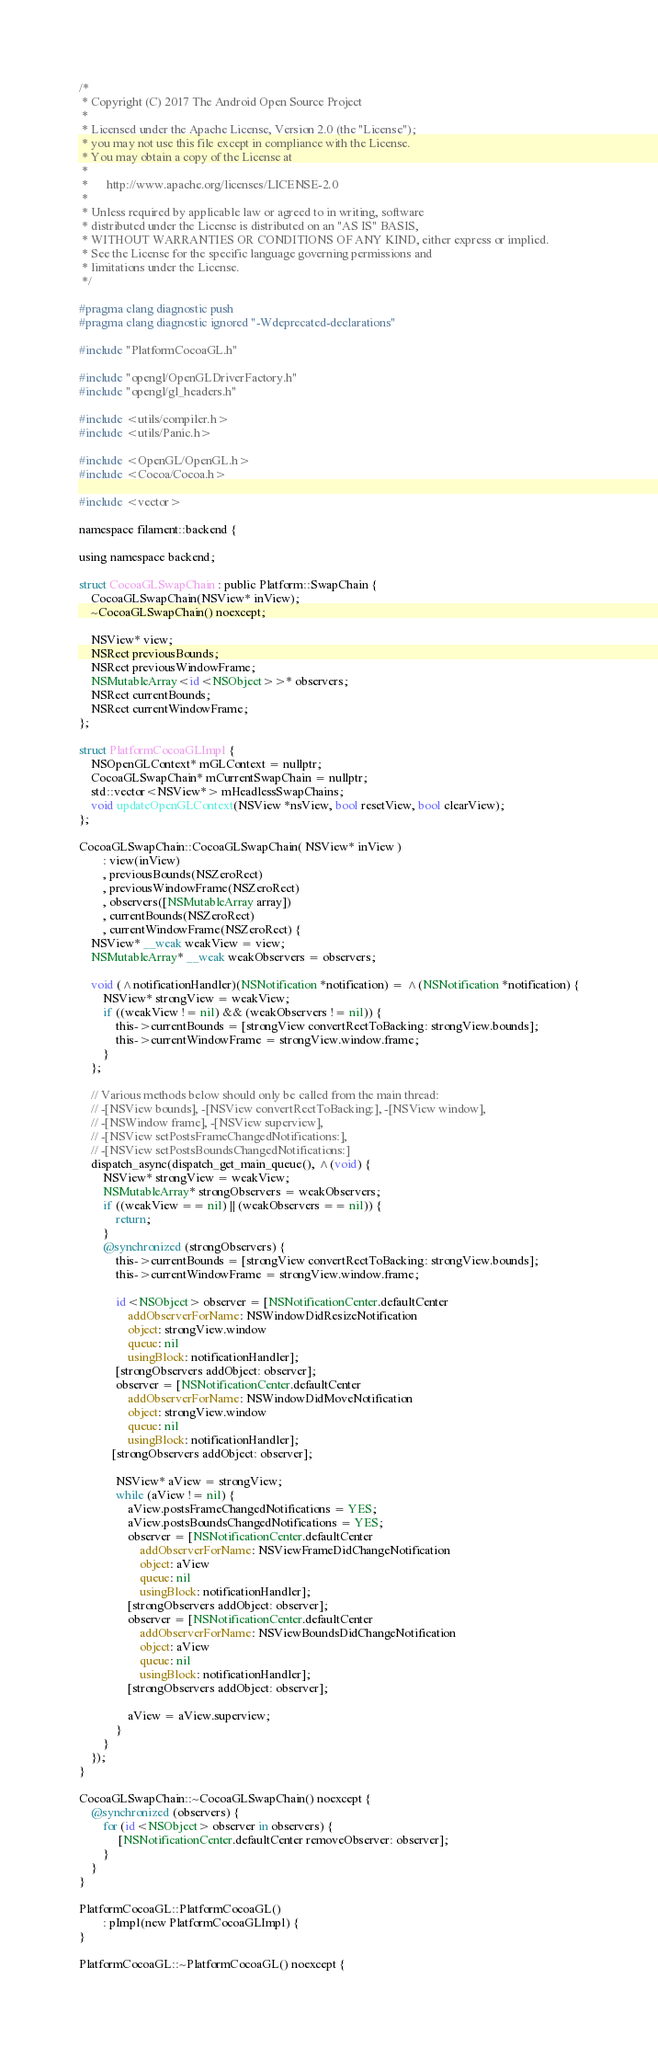<code> <loc_0><loc_0><loc_500><loc_500><_ObjectiveC_>/*
 * Copyright (C) 2017 The Android Open Source Project
 *
 * Licensed under the Apache License, Version 2.0 (the "License");
 * you may not use this file except in compliance with the License.
 * You may obtain a copy of the License at
 *
 *      http://www.apache.org/licenses/LICENSE-2.0
 *
 * Unless required by applicable law or agreed to in writing, software
 * distributed under the License is distributed on an "AS IS" BASIS,
 * WITHOUT WARRANTIES OR CONDITIONS OF ANY KIND, either express or implied.
 * See the License for the specific language governing permissions and
 * limitations under the License.
 */

#pragma clang diagnostic push
#pragma clang diagnostic ignored "-Wdeprecated-declarations"

#include "PlatformCocoaGL.h"

#include "opengl/OpenGLDriverFactory.h"
#include "opengl/gl_headers.h"

#include <utils/compiler.h>
#include <utils/Panic.h>

#include <OpenGL/OpenGL.h>
#include <Cocoa/Cocoa.h>

#include <vector>

namespace filament::backend {

using namespace backend;

struct CocoaGLSwapChain : public Platform::SwapChain {
    CocoaGLSwapChain(NSView* inView);
    ~CocoaGLSwapChain() noexcept;

    NSView* view;
    NSRect previousBounds;
    NSRect previousWindowFrame;
    NSMutableArray<id<NSObject>>* observers;
    NSRect currentBounds;
    NSRect currentWindowFrame;
};

struct PlatformCocoaGLImpl {
    NSOpenGLContext* mGLContext = nullptr;
    CocoaGLSwapChain* mCurrentSwapChain = nullptr;
    std::vector<NSView*> mHeadlessSwapChains;
    void updateOpenGLContext(NSView *nsView, bool resetView, bool clearView);
};

CocoaGLSwapChain::CocoaGLSwapChain( NSView* inView )
        : view(inView)
        , previousBounds(NSZeroRect)
        , previousWindowFrame(NSZeroRect)
        , observers([NSMutableArray array])
        , currentBounds(NSZeroRect)
        , currentWindowFrame(NSZeroRect) {
    NSView* __weak weakView = view;
    NSMutableArray* __weak weakObservers = observers;
    
    void (^notificationHandler)(NSNotification *notification) = ^(NSNotification *notification) {
        NSView* strongView = weakView;
        if ((weakView != nil) && (weakObservers != nil)) {
            this->currentBounds = [strongView convertRectToBacking: strongView.bounds];
            this->currentWindowFrame = strongView.window.frame;
        }
    };
    
    // Various methods below should only be called from the main thread:
    // -[NSView bounds], -[NSView convertRectToBacking:], -[NSView window],
    // -[NSWindow frame], -[NSView superview],
    // -[NSView setPostsFrameChangedNotifications:],
    // -[NSView setPostsBoundsChangedNotifications:]
    dispatch_async(dispatch_get_main_queue(), ^(void) {
        NSView* strongView = weakView;
        NSMutableArray* strongObservers = weakObservers;
        if ((weakView == nil) || (weakObservers == nil)) {
            return;
        }
        @synchronized (strongObservers) {
            this->currentBounds = [strongView convertRectToBacking: strongView.bounds];
            this->currentWindowFrame = strongView.window.frame;

            id<NSObject> observer = [NSNotificationCenter.defaultCenter
                addObserverForName: NSWindowDidResizeNotification
                object: strongView.window
                queue: nil
                usingBlock: notificationHandler];
            [strongObservers addObject: observer];
            observer = [NSNotificationCenter.defaultCenter
                addObserverForName: NSWindowDidMoveNotification
                object: strongView.window
                queue: nil
                usingBlock: notificationHandler];
           [strongObservers addObject: observer];

            NSView* aView = strongView;
            while (aView != nil) {
                aView.postsFrameChangedNotifications = YES;
                aView.postsBoundsChangedNotifications = YES;
                observer = [NSNotificationCenter.defaultCenter
                    addObserverForName: NSViewFrameDidChangeNotification
                    object: aView
                    queue: nil
                    usingBlock: notificationHandler];
                [strongObservers addObject: observer];
                observer = [NSNotificationCenter.defaultCenter
                    addObserverForName: NSViewBoundsDidChangeNotification
                    object: aView
                    queue: nil
                    usingBlock: notificationHandler];
                [strongObservers addObject: observer];
                
                aView = aView.superview;
            }
        }
    });
}

CocoaGLSwapChain::~CocoaGLSwapChain() noexcept {
    @synchronized (observers) {
        for (id<NSObject> observer in observers) {
             [NSNotificationCenter.defaultCenter removeObserver: observer];
        }
    }
}

PlatformCocoaGL::PlatformCocoaGL()
        : pImpl(new PlatformCocoaGLImpl) {
}

PlatformCocoaGL::~PlatformCocoaGL() noexcept {</code> 